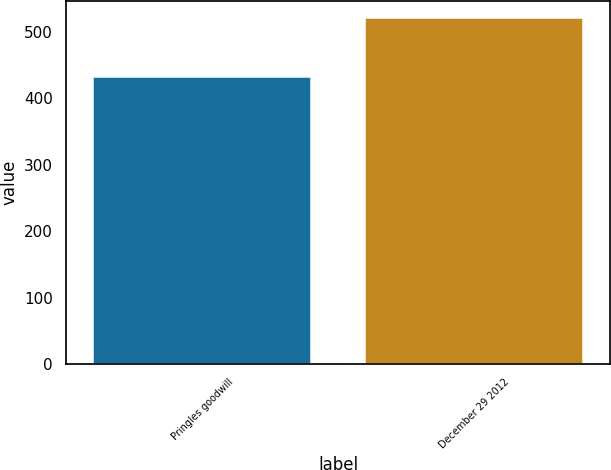Convert chart to OTSL. <chart><loc_0><loc_0><loc_500><loc_500><bar_chart><fcel>Pringles goodwill<fcel>December 29 2012<nl><fcel>432<fcel>520<nl></chart> 